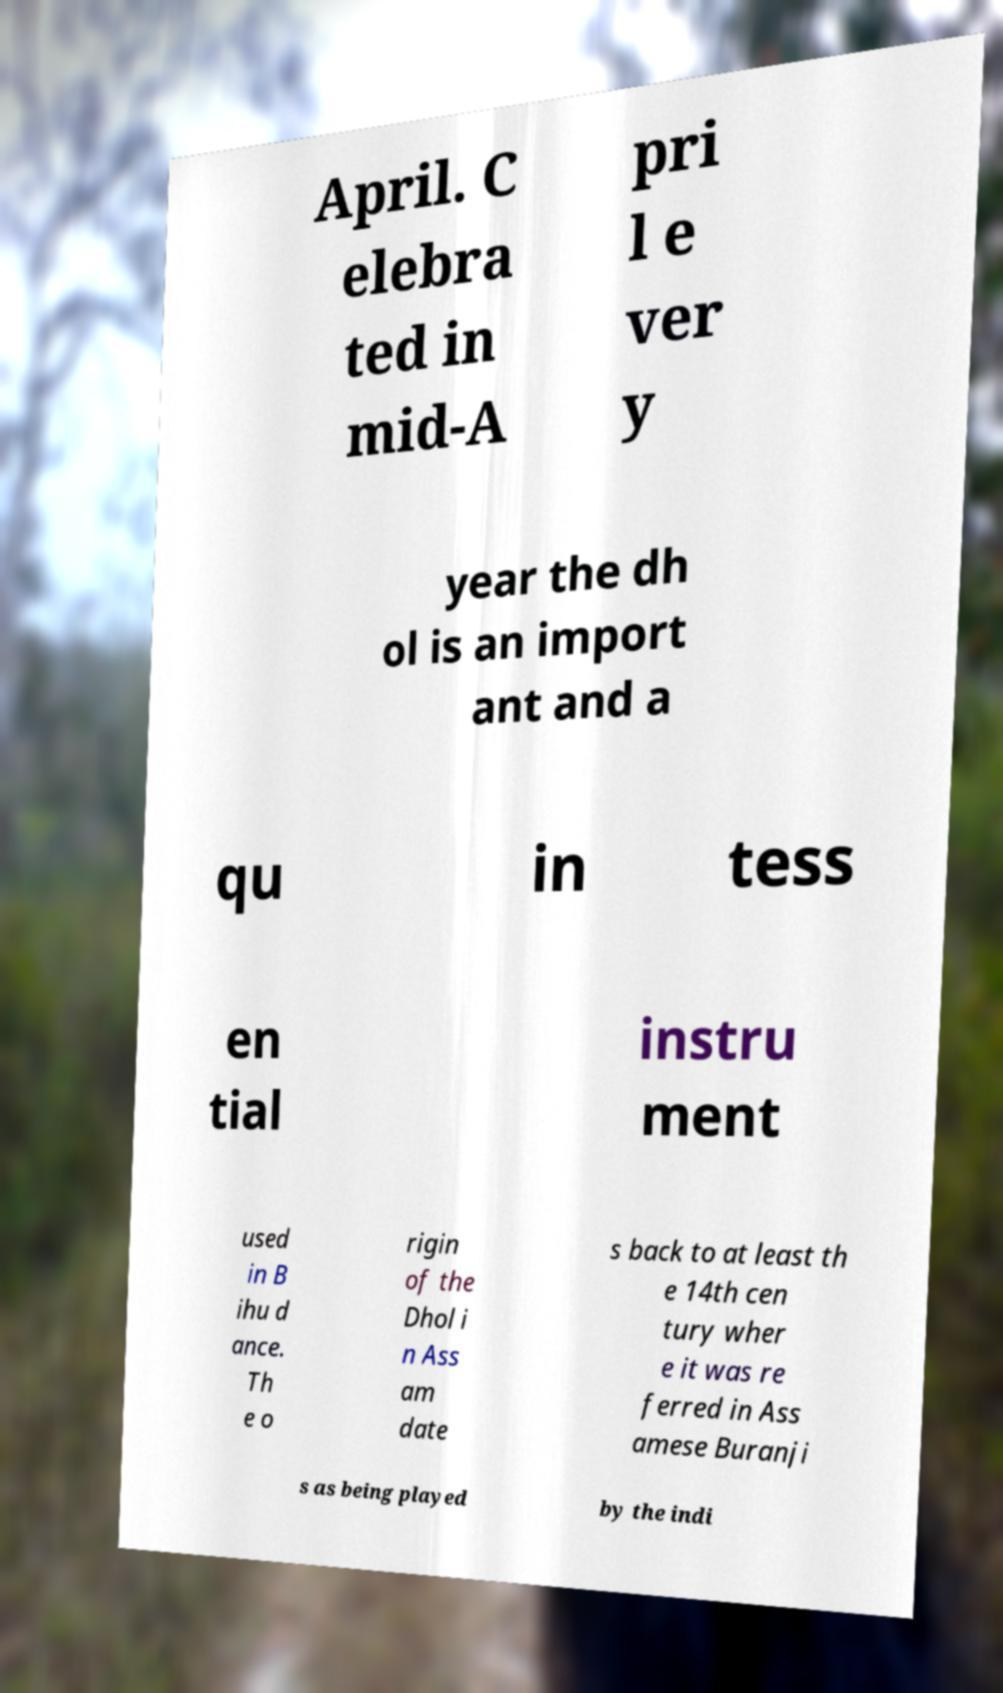Could you assist in decoding the text presented in this image and type it out clearly? April. C elebra ted in mid-A pri l e ver y year the dh ol is an import ant and a qu in tess en tial instru ment used in B ihu d ance. Th e o rigin of the Dhol i n Ass am date s back to at least th e 14th cen tury wher e it was re ferred in Ass amese Buranji s as being played by the indi 